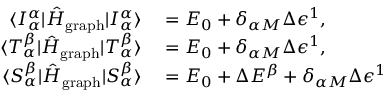<formula> <loc_0><loc_0><loc_500><loc_500>\begin{array} { r l } { \langle I _ { \alpha } ^ { \alpha } | \hat { H } _ { g r a p h } | I _ { \alpha } ^ { \alpha } \rangle } & = E _ { 0 } + \delta _ { \alpha M } \Delta \epsilon ^ { 1 } , } \\ { \langle T _ { \alpha } ^ { \beta } | \hat { H } _ { g r a p h } | T _ { \alpha } ^ { \beta } \rangle } & = E _ { 0 } + \delta _ { \alpha M } \Delta \epsilon ^ { 1 } , } \\ { \langle S _ { \alpha } ^ { \beta } | \hat { H } _ { g r a p h } | S _ { \alpha } ^ { \beta } \rangle } & = E _ { 0 } + \Delta E ^ { \beta } + \delta _ { \alpha M } \Delta \epsilon ^ { 1 } } \end{array}</formula> 